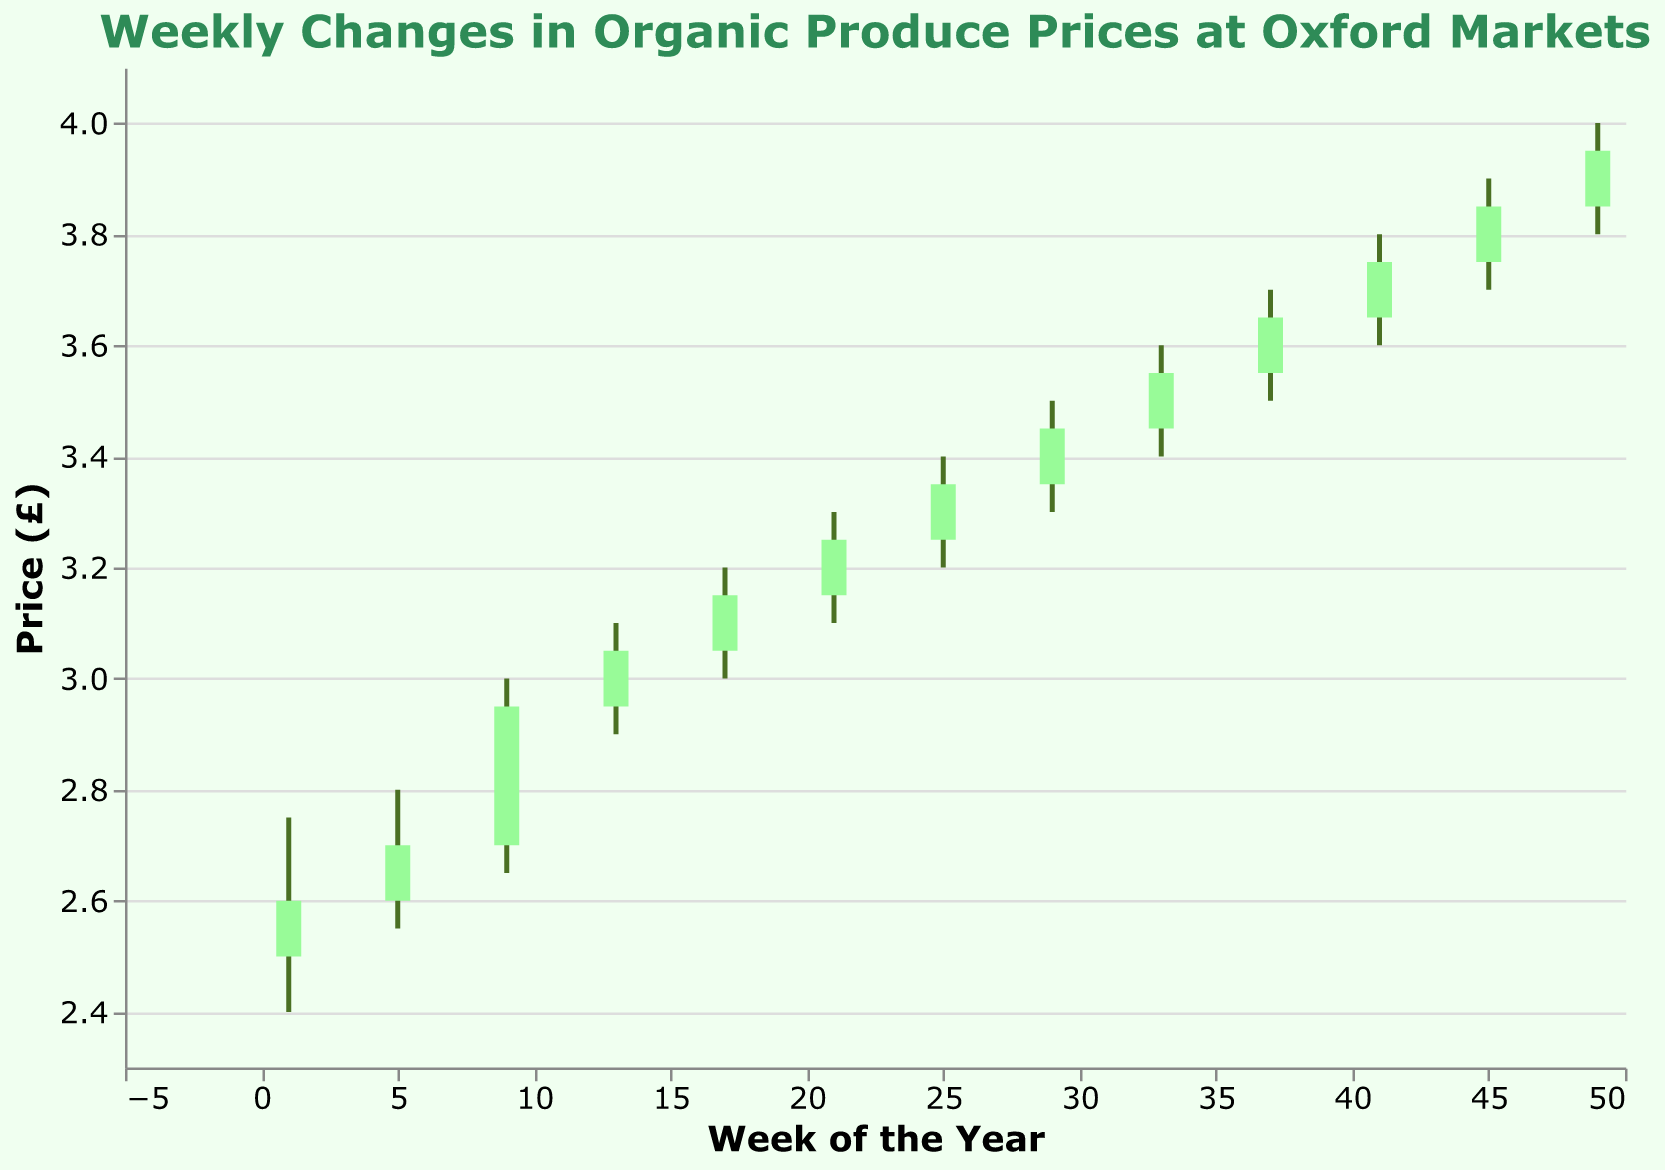What's the title of the chart? The title is displayed prominently at the top of the chart. It reads "Weekly Changes in Organic Produce Prices at Oxford Markets."
Answer: Weekly Changes in Organic Produce Prices at Oxford Markets What is the highest price recorded during the year? By examining the OHLC data points, we identify the highest price from the 'High' column, which happens in Week 49 at 4.00.
Answer: 4.00 How many weeks are represented in the chart? Each data point on the x-axis represents a week monitored throughout the year. We count the data points or review the "Week" column in the data, which gives us a total of 13 unique weeks.
Answer: 13 What was the price range in Week 9? The price range in Week 9 can be calculated by subtracting the 'Low' price from the 'High' price, which is 3.00 - 2.65.
Answer: 0.35 In which week did the price remain the most stable? To determine the stability, we look for the smallest difference between the 'High' and 'Low' prices. This occurs in Week 1, where the difference is 2.75 - 2.40 = 0.35.
Answer: Week 1 Which week saw the largest increase in the closing price compared to the opening price? Comparing the difference between 'Close' and 'Open' prices, we calculate the increase for each week and find the largest difference. The greatest increase is in Week 9, where the difference is 2.95 - 2.70 = 0.25.
Answer: Week 9 How does the closing price of Week 41 compare to Week 45? By examining the 'Close' prices for Week 41 and Week 45, we see a difference: Week 41 has a closing price of 3.75, and Week 45 is 3.85.
Answer: Week 45 is higher What is the average closing price throughout the weeks? We sum up all the 'Close' prices and divide by the number of weeks (13). (2.60 + 2.70 + 2.95 + 3.05 + 3.15 + 3.25 + 3.35 + 3.45 + 3.55 + 3.65 + 3.75 + 3.85 + 3.95) / 13 = 3.222.
Answer: 3.22 Which week experienced the highest weekly price volatility? Weekly price volatility is determined by the largest difference between the 'High' and 'Low' prices. Week 49 has the highest volatility, with a difference of 4.00 - 3.80 = 0.20.
Answer: Week 49 